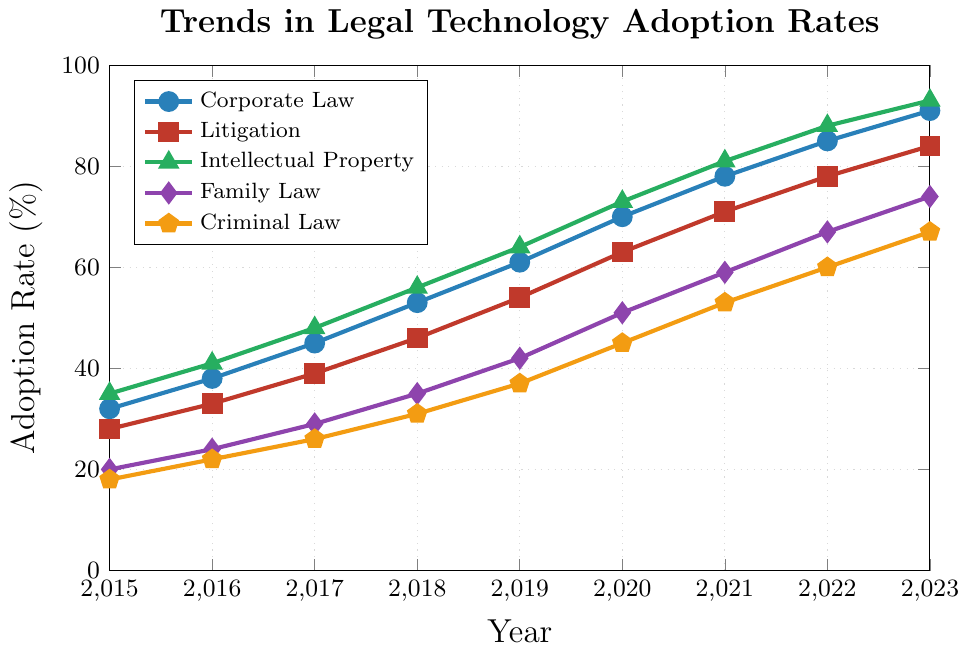What year did Family Law's technology adoption rate exceed 50%? To find this, locate the point where the line representing Family Law (purple) crosses 50% on the y-axis. Family Law's data point for 2020 is at 51%, which is the first year it exceeds 50%.
Answer: 2020 Which practice area showed the highest rate of technology adoption in 2021? Look at the data points in 2021 for all practice areas and identify the highest value. In 2021, Intellectual Property (green) is at 81%, which is the highest compared to others.
Answer: Intellectual Property How much did Corporate Law's technology adoption rate increase from 2015 to 2020? Subtract the adoption rate in 2015 from the rate in 2020 for Corporate Law (blue). The increase is 70% - 32% = 38%.
Answer: 38% Compare the adoption rate of Litigation and Criminal Law in 2019. Which had a higher rate and by how much? Find the 2019 rates for Litigation (red) and Criminal Law (orange). Litigation is at 54% and Criminal Law is at 37%. The difference is 54% - 37% = 17%.
Answer: Litigation by 17% What is the average adoption rate of Intellectual Property across all the years presented? Add up all the adoption rate values for Intellectual Property from 2015 to 2023 and divide by the number of years. \[(35+41+48+56+64+73+81+88+93)/9 ≈ 64.1%\]
Answer: 64.1% Did any practice area have the same adoption rate in two different years? Check the trend lines for any practice area that intersects or remains constant at certain y-values across different years. None of the lines intersect at the same value.
Answer: No How does the adoption rate in Family Law in 2023 compare to Corporate Law in 2019? Identify the rates for Family Law in 2023 and Corporate Law in 2019 by looking at their respective points. Family Law in 2023 is 74%, and Corporate Law in 2019 is 61%, so Family Law in 2023 is higher.
Answer: Family Law in 2023 is higher Calculate the total increase in adoption rate for Criminal Law from 2015 to 2023. Subtract the 2015 adoption rate from the 2023 rate for Criminal Law (orange). The increase is 67% - 18% = 49%.
Answer: 49% Which year did Litigation surpass the 60% adoption rate? Look at the data points for Litigation (red) and find the first year it crosses 60%. This occurred in 2020, where the rate is 63%.
Answer: 2020 Which practice area had the second-highest adoption rate in 2018? Compare the rates of all practice areas in 2018. Corporate Law is 53%, Litigation 46%, Intellectual Property 56%, Family Law 35%, and Criminal Law 31%. The second-highest is Corporate Law at 53%.
Answer: Corporate Law 